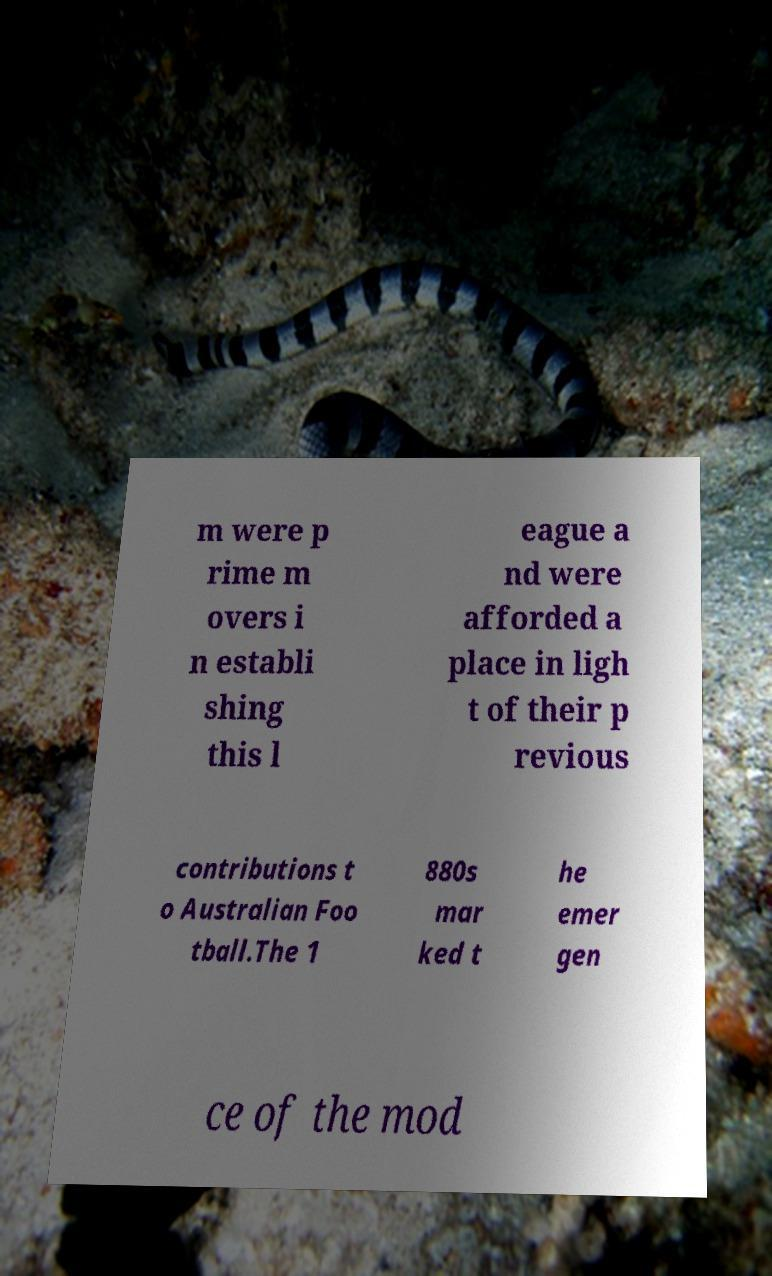I need the written content from this picture converted into text. Can you do that? m were p rime m overs i n establi shing this l eague a nd were afforded a place in ligh t of their p revious contributions t o Australian Foo tball.The 1 880s mar ked t he emer gen ce of the mod 